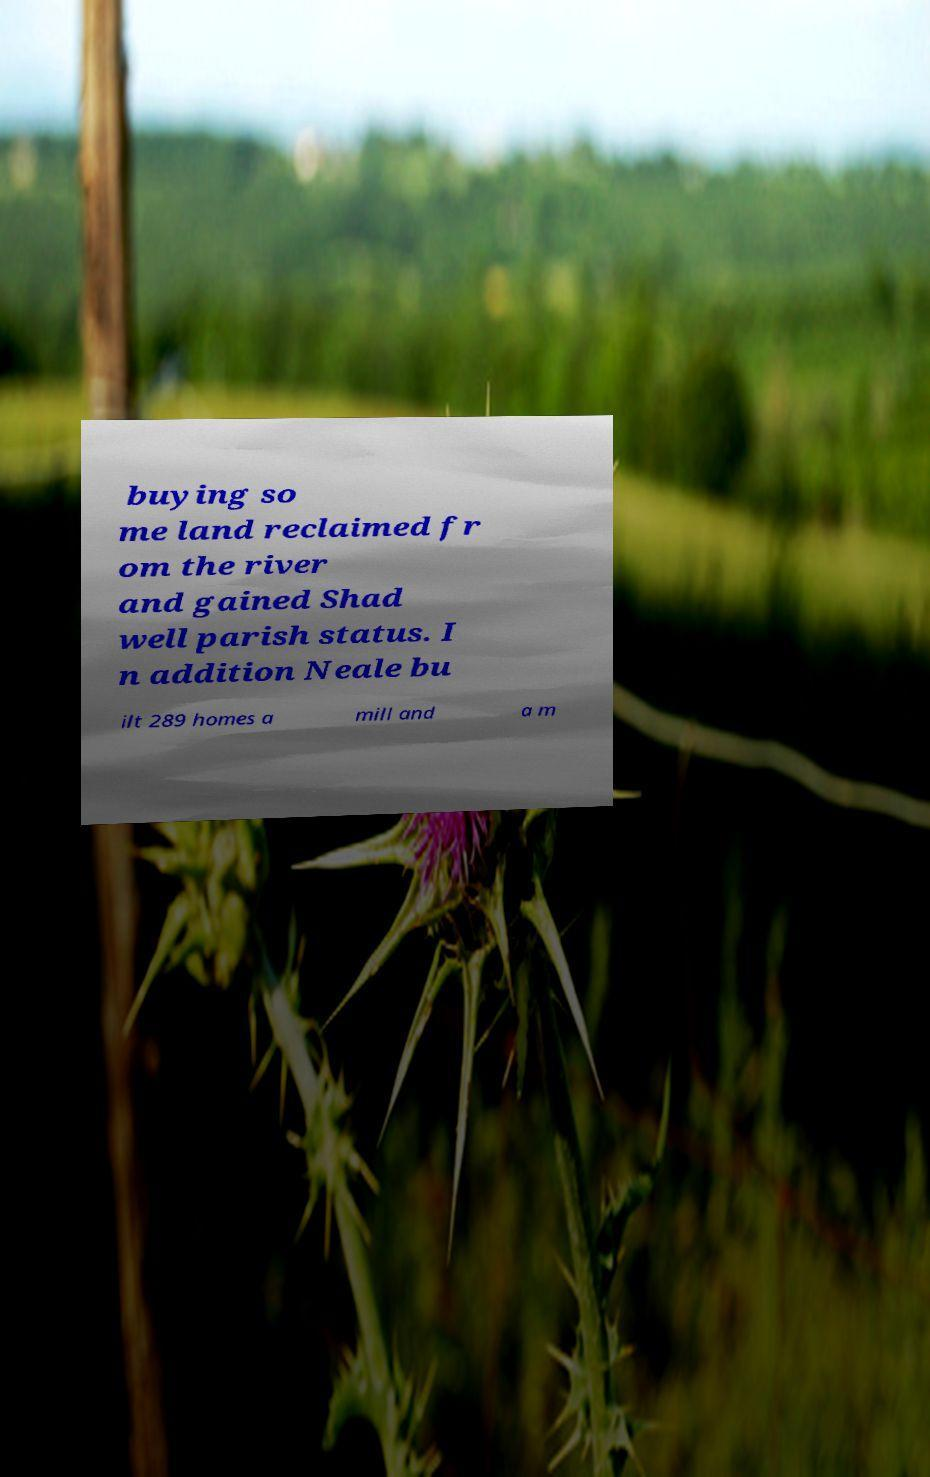Can you read and provide the text displayed in the image?This photo seems to have some interesting text. Can you extract and type it out for me? buying so me land reclaimed fr om the river and gained Shad well parish status. I n addition Neale bu ilt 289 homes a mill and a m 